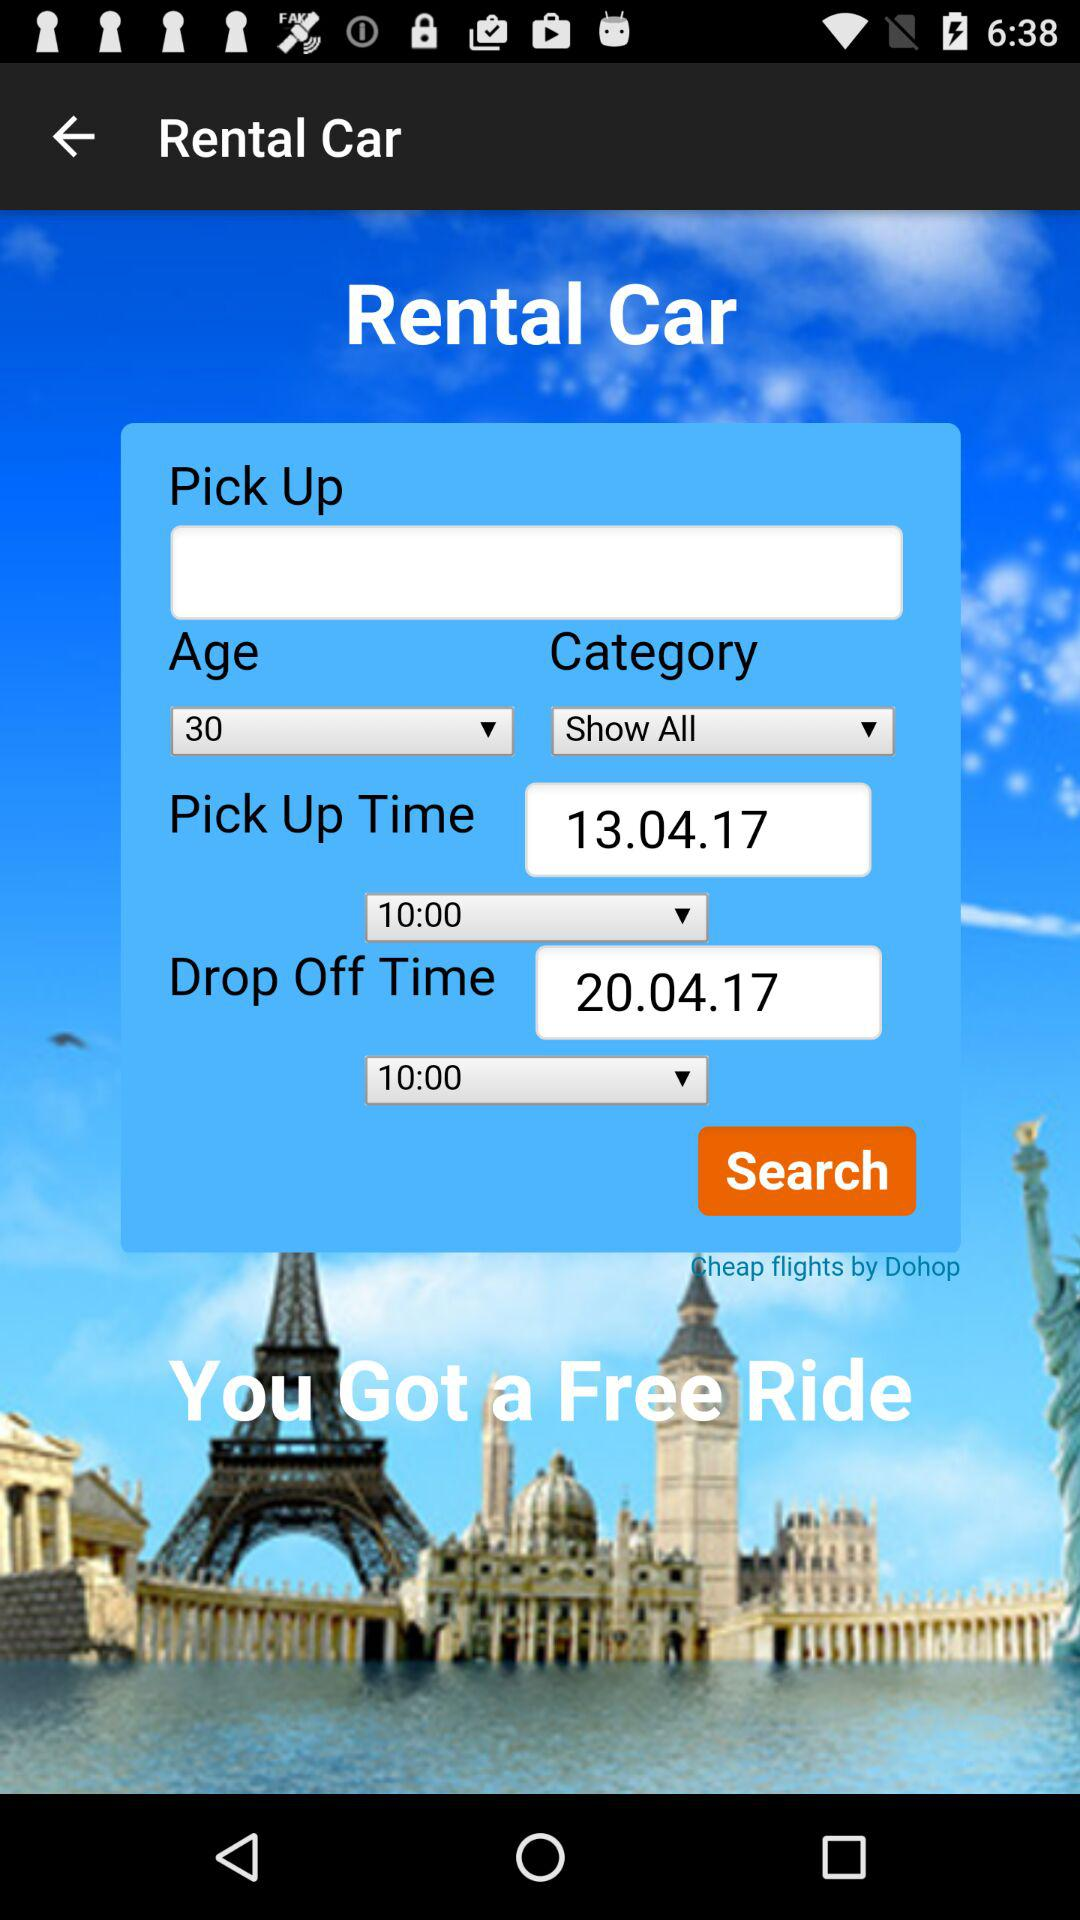What is the pick-up time? The pick-up time is 10:00. 